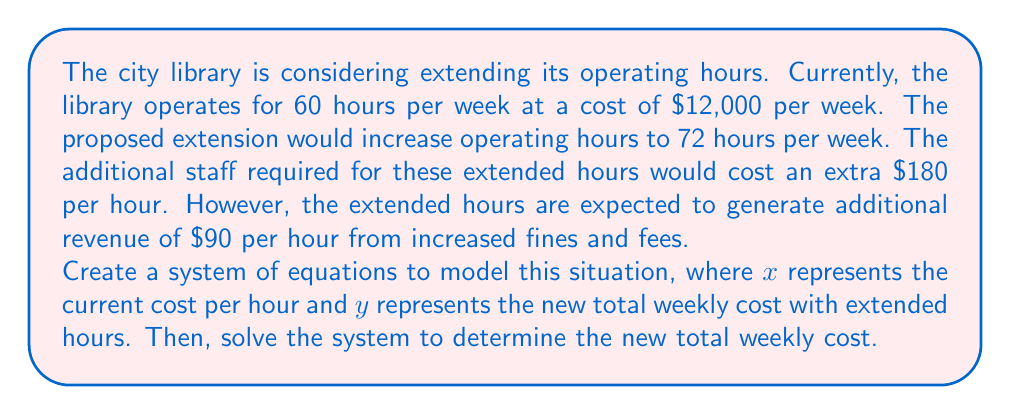Teach me how to tackle this problem. Let's approach this problem step-by-step:

1) First, let's set up our equations based on the given information:

   Equation 1: Current situation
   $$60x = 12000$$

   Equation 2: New situation
   $$72x + 72(180) - 72(90) = y$$

2) From Equation 1, we can solve for $x$:
   $$x = \frac{12000}{60} = 200$$

   So, the current cost per hour is $200.

3) Now that we know $x$, we can substitute this into Equation 2:
   $$72(200) + 72(180) - 72(90) = y$$

4) Let's solve this equation:
   $$14400 + 12960 - 6480 = y$$
   $$20880 = y$$

5) Therefore, the new total weekly cost ($y$) would be $20,880.

This system of equations allows us to model both the current situation and the proposed changes, taking into account the additional costs and revenues associated with extended hours.
Answer: The new total weekly cost with extended library hours would be $20,880. 